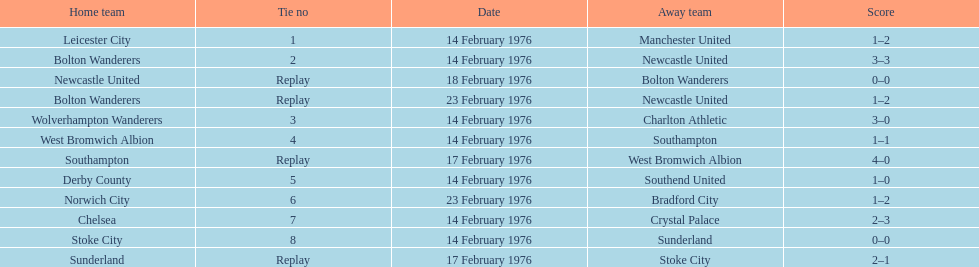Who had a better score, manchester united or wolverhampton wanderers? Wolverhampton Wanderers. 